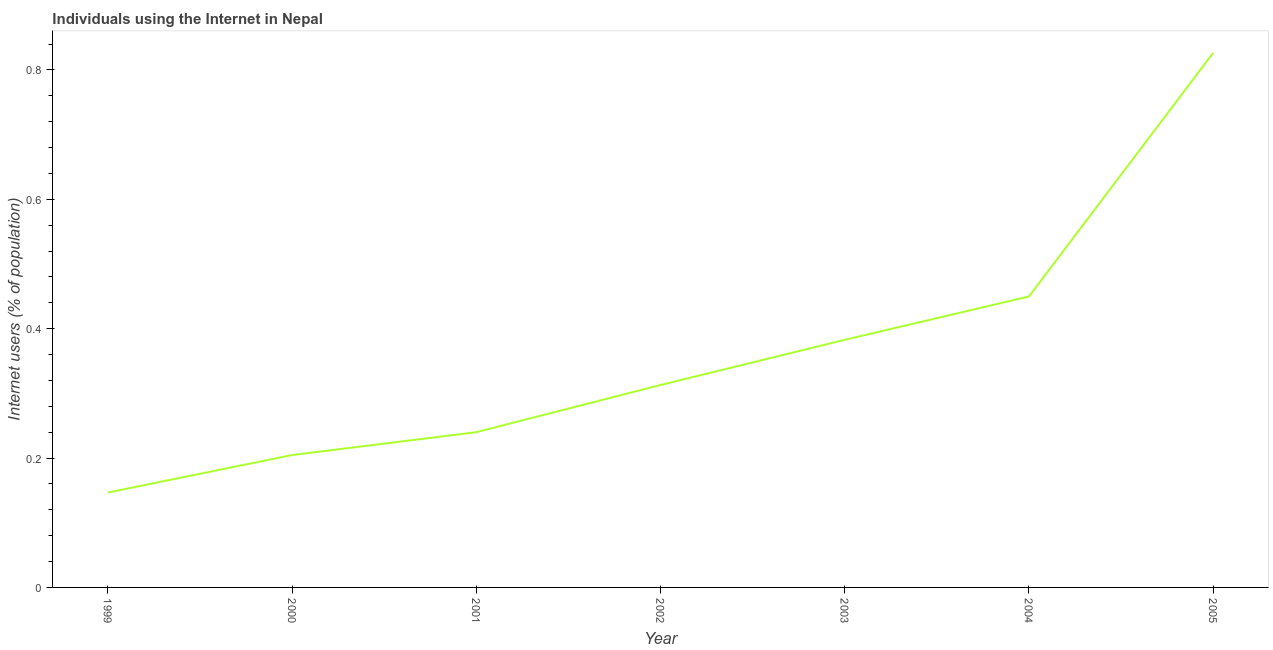What is the number of internet users in 2003?
Give a very brief answer. 0.38. Across all years, what is the maximum number of internet users?
Make the answer very short. 0.83. Across all years, what is the minimum number of internet users?
Provide a short and direct response. 0.15. What is the sum of the number of internet users?
Offer a very short reply. 2.56. What is the difference between the number of internet users in 2000 and 2005?
Your response must be concise. -0.62. What is the average number of internet users per year?
Give a very brief answer. 0.37. What is the median number of internet users?
Give a very brief answer. 0.31. Do a majority of the years between 1999 and 2000 (inclusive) have number of internet users greater than 0.56 %?
Make the answer very short. No. What is the ratio of the number of internet users in 2000 to that in 2002?
Make the answer very short. 0.65. What is the difference between the highest and the second highest number of internet users?
Your answer should be very brief. 0.38. Is the sum of the number of internet users in 2001 and 2002 greater than the maximum number of internet users across all years?
Your answer should be very brief. No. What is the difference between the highest and the lowest number of internet users?
Provide a short and direct response. 0.68. Does the number of internet users monotonically increase over the years?
Offer a very short reply. Yes. How many years are there in the graph?
Offer a very short reply. 7. What is the difference between two consecutive major ticks on the Y-axis?
Provide a short and direct response. 0.2. Are the values on the major ticks of Y-axis written in scientific E-notation?
Ensure brevity in your answer.  No. Does the graph contain grids?
Give a very brief answer. No. What is the title of the graph?
Provide a short and direct response. Individuals using the Internet in Nepal. What is the label or title of the Y-axis?
Your answer should be compact. Internet users (% of population). What is the Internet users (% of population) in 1999?
Provide a short and direct response. 0.15. What is the Internet users (% of population) in 2000?
Provide a short and direct response. 0.2. What is the Internet users (% of population) of 2001?
Offer a very short reply. 0.24. What is the Internet users (% of population) of 2002?
Your answer should be very brief. 0.31. What is the Internet users (% of population) of 2003?
Offer a terse response. 0.38. What is the Internet users (% of population) of 2004?
Make the answer very short. 0.45. What is the Internet users (% of population) in 2005?
Provide a succinct answer. 0.83. What is the difference between the Internet users (% of population) in 1999 and 2000?
Keep it short and to the point. -0.06. What is the difference between the Internet users (% of population) in 1999 and 2001?
Provide a succinct answer. -0.09. What is the difference between the Internet users (% of population) in 1999 and 2002?
Provide a succinct answer. -0.17. What is the difference between the Internet users (% of population) in 1999 and 2003?
Your answer should be compact. -0.24. What is the difference between the Internet users (% of population) in 1999 and 2004?
Make the answer very short. -0.3. What is the difference between the Internet users (% of population) in 1999 and 2005?
Provide a short and direct response. -0.68. What is the difference between the Internet users (% of population) in 2000 and 2001?
Make the answer very short. -0.04. What is the difference between the Internet users (% of population) in 2000 and 2002?
Provide a short and direct response. -0.11. What is the difference between the Internet users (% of population) in 2000 and 2003?
Keep it short and to the point. -0.18. What is the difference between the Internet users (% of population) in 2000 and 2004?
Provide a short and direct response. -0.25. What is the difference between the Internet users (% of population) in 2000 and 2005?
Your response must be concise. -0.62. What is the difference between the Internet users (% of population) in 2001 and 2002?
Give a very brief answer. -0.07. What is the difference between the Internet users (% of population) in 2001 and 2003?
Provide a succinct answer. -0.14. What is the difference between the Internet users (% of population) in 2001 and 2004?
Offer a very short reply. -0.21. What is the difference between the Internet users (% of population) in 2001 and 2005?
Keep it short and to the point. -0.59. What is the difference between the Internet users (% of population) in 2002 and 2003?
Keep it short and to the point. -0.07. What is the difference between the Internet users (% of population) in 2002 and 2004?
Your response must be concise. -0.14. What is the difference between the Internet users (% of population) in 2002 and 2005?
Make the answer very short. -0.51. What is the difference between the Internet users (% of population) in 2003 and 2004?
Your response must be concise. -0.07. What is the difference between the Internet users (% of population) in 2003 and 2005?
Offer a very short reply. -0.44. What is the difference between the Internet users (% of population) in 2004 and 2005?
Provide a short and direct response. -0.38. What is the ratio of the Internet users (% of population) in 1999 to that in 2000?
Your response must be concise. 0.72. What is the ratio of the Internet users (% of population) in 1999 to that in 2001?
Your answer should be very brief. 0.61. What is the ratio of the Internet users (% of population) in 1999 to that in 2002?
Offer a terse response. 0.47. What is the ratio of the Internet users (% of population) in 1999 to that in 2003?
Offer a very short reply. 0.38. What is the ratio of the Internet users (% of population) in 1999 to that in 2004?
Your answer should be compact. 0.33. What is the ratio of the Internet users (% of population) in 1999 to that in 2005?
Offer a very short reply. 0.18. What is the ratio of the Internet users (% of population) in 2000 to that in 2001?
Provide a short and direct response. 0.85. What is the ratio of the Internet users (% of population) in 2000 to that in 2002?
Offer a terse response. 0.65. What is the ratio of the Internet users (% of population) in 2000 to that in 2003?
Your answer should be compact. 0.54. What is the ratio of the Internet users (% of population) in 2000 to that in 2004?
Keep it short and to the point. 0.46. What is the ratio of the Internet users (% of population) in 2000 to that in 2005?
Make the answer very short. 0.25. What is the ratio of the Internet users (% of population) in 2001 to that in 2002?
Your answer should be compact. 0.77. What is the ratio of the Internet users (% of population) in 2001 to that in 2003?
Your response must be concise. 0.63. What is the ratio of the Internet users (% of population) in 2001 to that in 2004?
Keep it short and to the point. 0.53. What is the ratio of the Internet users (% of population) in 2001 to that in 2005?
Ensure brevity in your answer.  0.29. What is the ratio of the Internet users (% of population) in 2002 to that in 2003?
Offer a very short reply. 0.82. What is the ratio of the Internet users (% of population) in 2002 to that in 2004?
Provide a short and direct response. 0.7. What is the ratio of the Internet users (% of population) in 2002 to that in 2005?
Offer a terse response. 0.38. What is the ratio of the Internet users (% of population) in 2003 to that in 2004?
Provide a short and direct response. 0.85. What is the ratio of the Internet users (% of population) in 2003 to that in 2005?
Keep it short and to the point. 0.46. What is the ratio of the Internet users (% of population) in 2004 to that in 2005?
Your answer should be very brief. 0.54. 